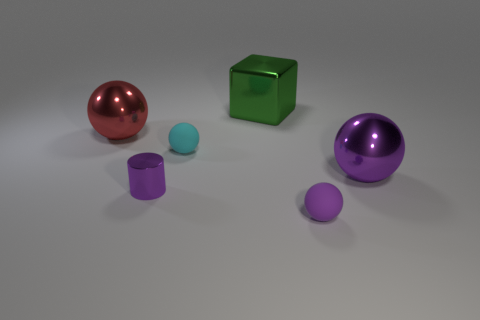Is the number of blocks behind the green block the same as the number of big cubes?
Keep it short and to the point. No. Is the size of the metallic sphere that is in front of the red metal object the same as the shiny thing that is in front of the big purple shiny ball?
Your response must be concise. No. Are there any tiny balls behind the shiny ball that is to the left of the purple ball that is behind the tiny cylinder?
Keep it short and to the point. No. Are there any other things that have the same color as the small metallic object?
Provide a short and direct response. Yes. How big is the shiny object on the right side of the tiny purple matte sphere?
Offer a terse response. Large. What size is the matte object that is behind the small purple rubber sphere in front of the purple shiny thing on the left side of the large purple shiny object?
Your answer should be compact. Small. What color is the tiny matte thing behind the big ball that is in front of the big red metallic sphere?
Offer a very short reply. Cyan. There is a small purple thing that is the same shape as the cyan rubber thing; what material is it?
Offer a very short reply. Rubber. Is there any other thing that has the same material as the large purple object?
Offer a terse response. Yes. There is a big red thing; are there any small purple cylinders behind it?
Your response must be concise. No. 